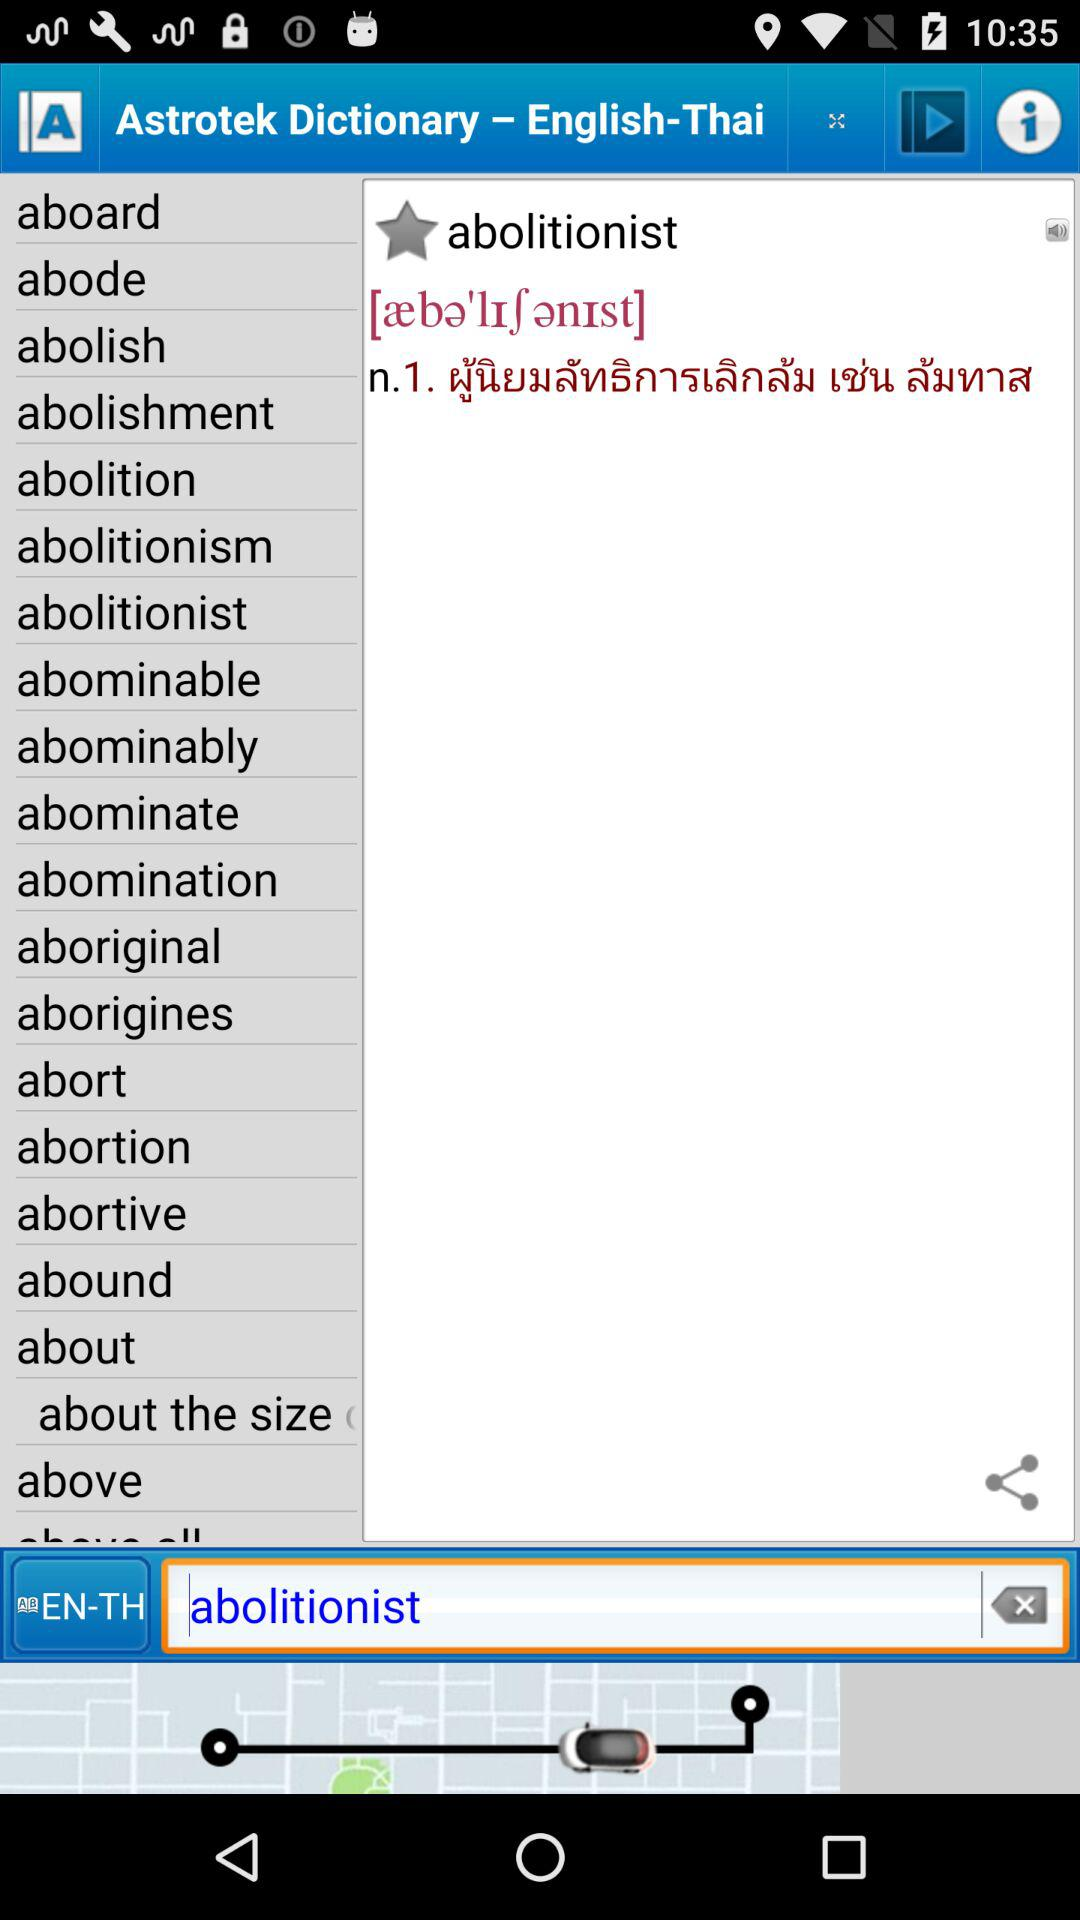What's the typed word to know the meaning in Thai? The typed word to know the meaning in Thai is abolitionist. 